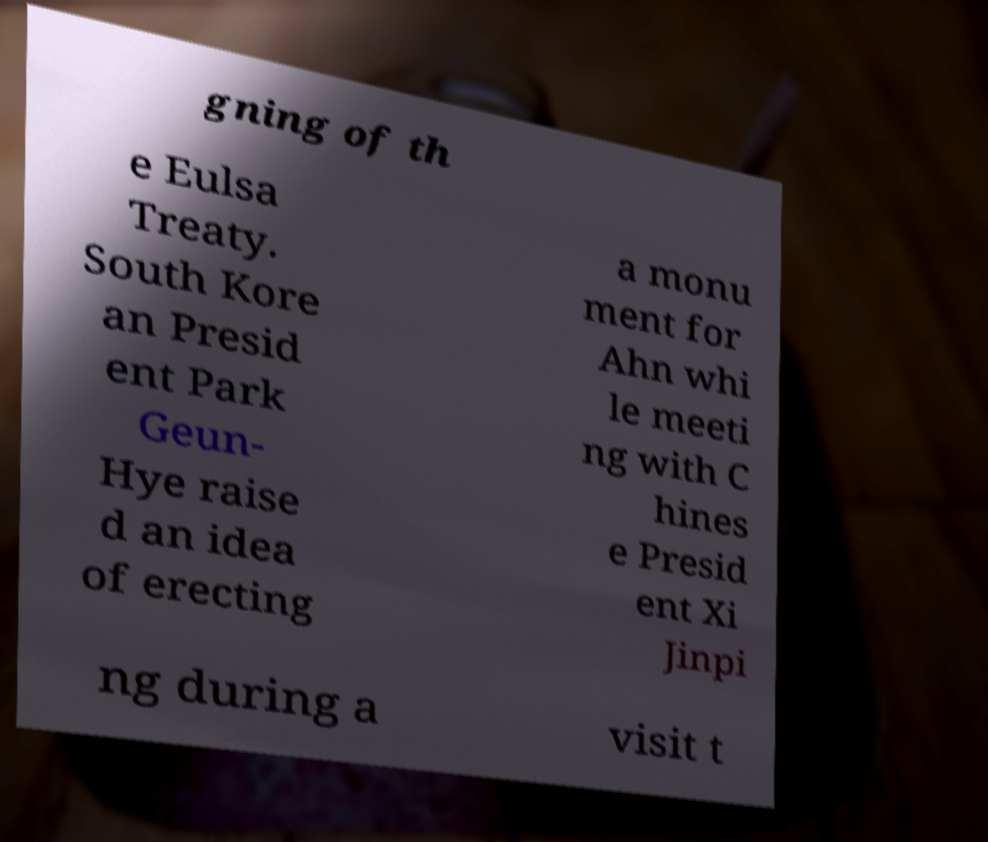For documentation purposes, I need the text within this image transcribed. Could you provide that? gning of th e Eulsa Treaty. South Kore an Presid ent Park Geun- Hye raise d an idea of erecting a monu ment for Ahn whi le meeti ng with C hines e Presid ent Xi Jinpi ng during a visit t 